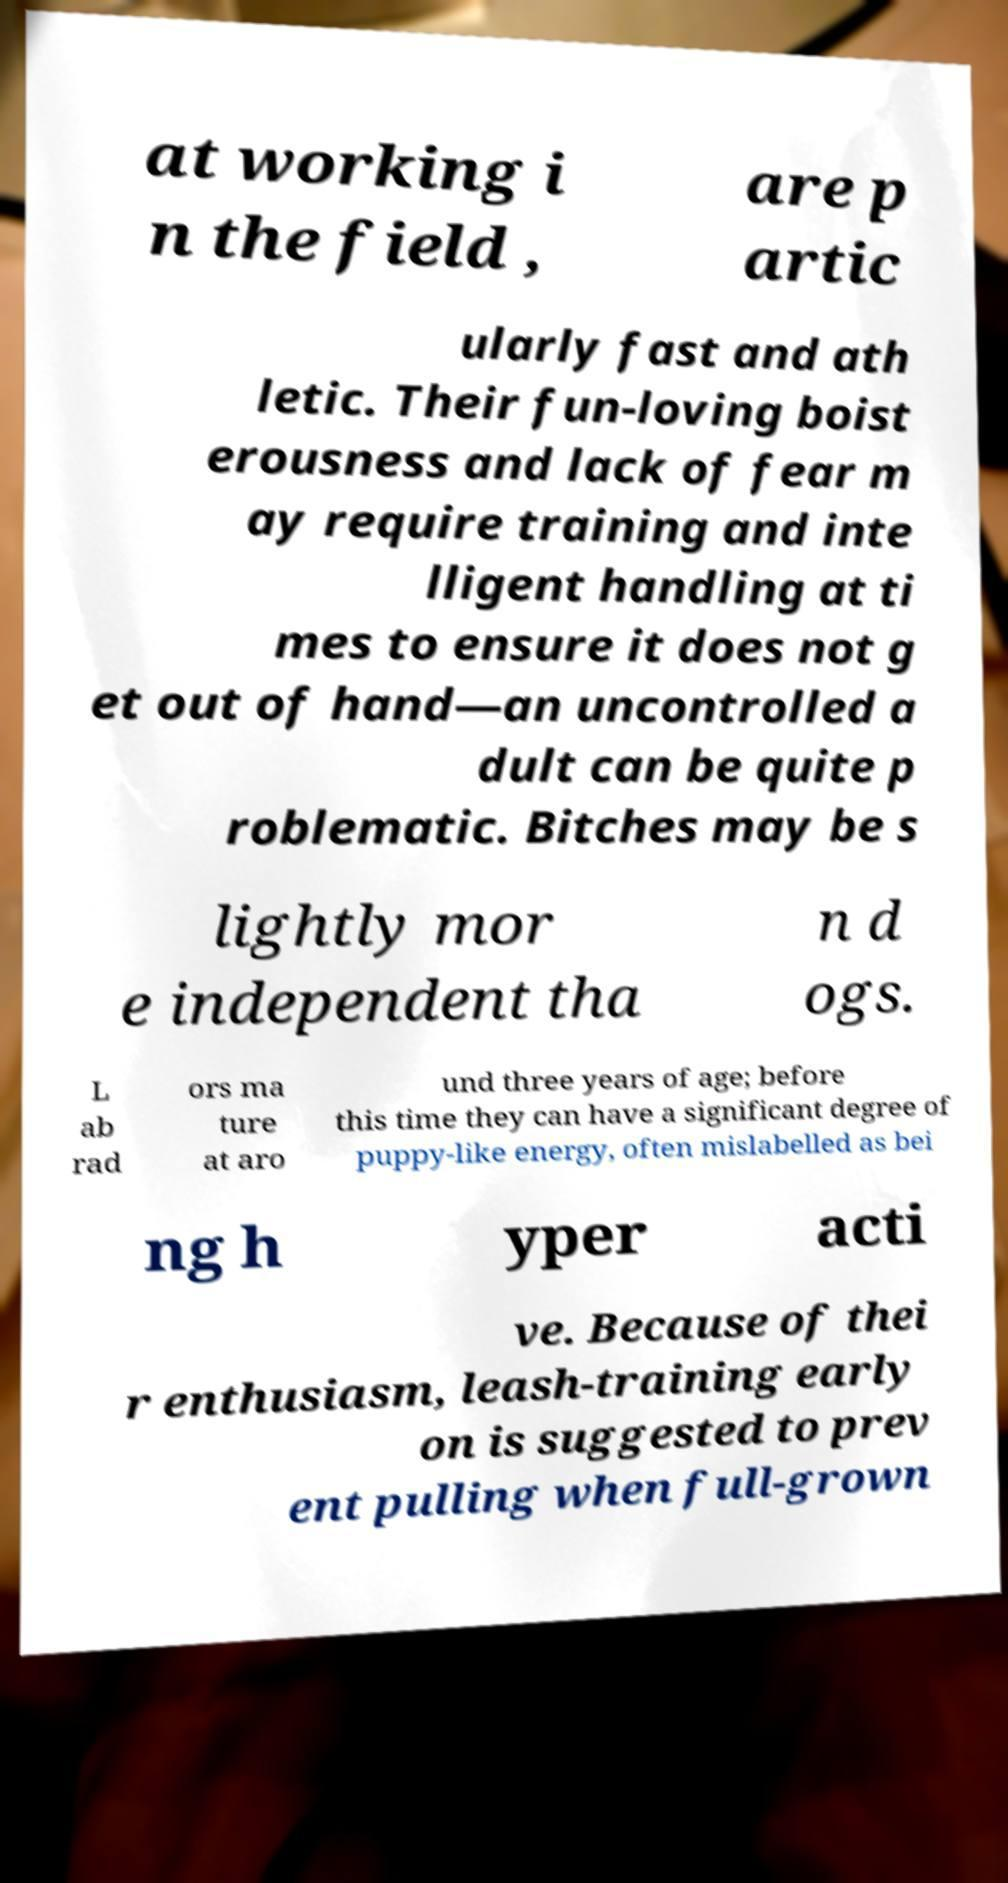Can you read and provide the text displayed in the image?This photo seems to have some interesting text. Can you extract and type it out for me? at working i n the field , are p artic ularly fast and ath letic. Their fun-loving boist erousness and lack of fear m ay require training and inte lligent handling at ti mes to ensure it does not g et out of hand—an uncontrolled a dult can be quite p roblematic. Bitches may be s lightly mor e independent tha n d ogs. L ab rad ors ma ture at aro und three years of age; before this time they can have a significant degree of puppy-like energy, often mislabelled as bei ng h yper acti ve. Because of thei r enthusiasm, leash-training early on is suggested to prev ent pulling when full-grown 